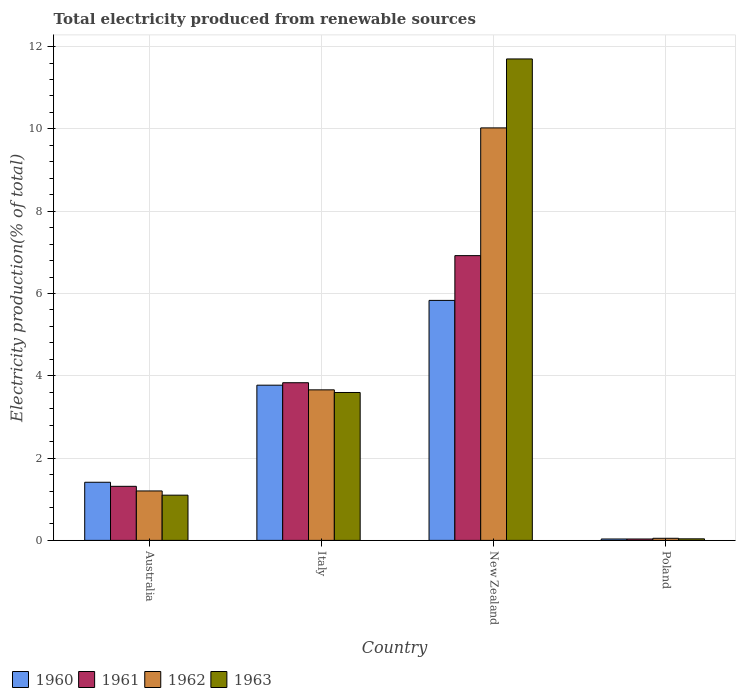How many different coloured bars are there?
Keep it short and to the point. 4. Are the number of bars per tick equal to the number of legend labels?
Your response must be concise. Yes. Are the number of bars on each tick of the X-axis equal?
Give a very brief answer. Yes. How many bars are there on the 3rd tick from the left?
Your answer should be compact. 4. How many bars are there on the 2nd tick from the right?
Your answer should be very brief. 4. What is the total electricity produced in 1960 in New Zealand?
Your answer should be very brief. 5.83. Across all countries, what is the maximum total electricity produced in 1962?
Give a very brief answer. 10.02. Across all countries, what is the minimum total electricity produced in 1960?
Provide a succinct answer. 0.03. In which country was the total electricity produced in 1961 maximum?
Give a very brief answer. New Zealand. What is the total total electricity produced in 1963 in the graph?
Offer a very short reply. 16.43. What is the difference between the total electricity produced in 1961 in Australia and that in New Zealand?
Make the answer very short. -5.61. What is the difference between the total electricity produced in 1963 in Australia and the total electricity produced in 1961 in New Zealand?
Your answer should be very brief. -5.82. What is the average total electricity produced in 1962 per country?
Your answer should be very brief. 3.73. What is the difference between the total electricity produced of/in 1961 and total electricity produced of/in 1963 in Italy?
Give a very brief answer. 0.24. What is the ratio of the total electricity produced in 1960 in New Zealand to that in Poland?
Give a very brief answer. 170.79. Is the total electricity produced in 1960 in Australia less than that in Poland?
Keep it short and to the point. No. What is the difference between the highest and the second highest total electricity produced in 1962?
Offer a very short reply. -8.82. What is the difference between the highest and the lowest total electricity produced in 1963?
Make the answer very short. 11.66. Is the sum of the total electricity produced in 1963 in Italy and Poland greater than the maximum total electricity produced in 1960 across all countries?
Offer a terse response. No. What does the 2nd bar from the left in Poland represents?
Offer a terse response. 1961. What does the 1st bar from the right in Italy represents?
Make the answer very short. 1963. Is it the case that in every country, the sum of the total electricity produced in 1963 and total electricity produced in 1961 is greater than the total electricity produced in 1962?
Make the answer very short. Yes. How many bars are there?
Offer a terse response. 16. What is the difference between two consecutive major ticks on the Y-axis?
Make the answer very short. 2. Does the graph contain any zero values?
Provide a short and direct response. No. Does the graph contain grids?
Your response must be concise. Yes. How many legend labels are there?
Your answer should be compact. 4. What is the title of the graph?
Provide a succinct answer. Total electricity produced from renewable sources. Does "1972" appear as one of the legend labels in the graph?
Give a very brief answer. No. What is the label or title of the Y-axis?
Offer a very short reply. Electricity production(% of total). What is the Electricity production(% of total) in 1960 in Australia?
Your answer should be very brief. 1.41. What is the Electricity production(% of total) in 1961 in Australia?
Ensure brevity in your answer.  1.31. What is the Electricity production(% of total) of 1962 in Australia?
Keep it short and to the point. 1.2. What is the Electricity production(% of total) of 1963 in Australia?
Provide a succinct answer. 1.1. What is the Electricity production(% of total) of 1960 in Italy?
Provide a succinct answer. 3.77. What is the Electricity production(% of total) in 1961 in Italy?
Keep it short and to the point. 3.83. What is the Electricity production(% of total) in 1962 in Italy?
Your answer should be compact. 3.66. What is the Electricity production(% of total) of 1963 in Italy?
Your response must be concise. 3.59. What is the Electricity production(% of total) in 1960 in New Zealand?
Your answer should be very brief. 5.83. What is the Electricity production(% of total) of 1961 in New Zealand?
Provide a short and direct response. 6.92. What is the Electricity production(% of total) in 1962 in New Zealand?
Your response must be concise. 10.02. What is the Electricity production(% of total) in 1963 in New Zealand?
Ensure brevity in your answer.  11.7. What is the Electricity production(% of total) in 1960 in Poland?
Offer a terse response. 0.03. What is the Electricity production(% of total) in 1961 in Poland?
Give a very brief answer. 0.03. What is the Electricity production(% of total) in 1962 in Poland?
Your response must be concise. 0.05. What is the Electricity production(% of total) of 1963 in Poland?
Keep it short and to the point. 0.04. Across all countries, what is the maximum Electricity production(% of total) in 1960?
Offer a very short reply. 5.83. Across all countries, what is the maximum Electricity production(% of total) of 1961?
Keep it short and to the point. 6.92. Across all countries, what is the maximum Electricity production(% of total) of 1962?
Your answer should be compact. 10.02. Across all countries, what is the maximum Electricity production(% of total) in 1963?
Your answer should be compact. 11.7. Across all countries, what is the minimum Electricity production(% of total) of 1960?
Provide a short and direct response. 0.03. Across all countries, what is the minimum Electricity production(% of total) of 1961?
Offer a very short reply. 0.03. Across all countries, what is the minimum Electricity production(% of total) of 1962?
Offer a very short reply. 0.05. Across all countries, what is the minimum Electricity production(% of total) in 1963?
Your answer should be compact. 0.04. What is the total Electricity production(% of total) in 1960 in the graph?
Provide a succinct answer. 11.05. What is the total Electricity production(% of total) of 1962 in the graph?
Your response must be concise. 14.94. What is the total Electricity production(% of total) in 1963 in the graph?
Provide a short and direct response. 16.43. What is the difference between the Electricity production(% of total) in 1960 in Australia and that in Italy?
Ensure brevity in your answer.  -2.36. What is the difference between the Electricity production(% of total) of 1961 in Australia and that in Italy?
Offer a terse response. -2.52. What is the difference between the Electricity production(% of total) of 1962 in Australia and that in Italy?
Make the answer very short. -2.46. What is the difference between the Electricity production(% of total) of 1963 in Australia and that in Italy?
Your response must be concise. -2.5. What is the difference between the Electricity production(% of total) in 1960 in Australia and that in New Zealand?
Make the answer very short. -4.42. What is the difference between the Electricity production(% of total) in 1961 in Australia and that in New Zealand?
Provide a succinct answer. -5.61. What is the difference between the Electricity production(% of total) of 1962 in Australia and that in New Zealand?
Offer a terse response. -8.82. What is the difference between the Electricity production(% of total) of 1963 in Australia and that in New Zealand?
Keep it short and to the point. -10.6. What is the difference between the Electricity production(% of total) of 1960 in Australia and that in Poland?
Your answer should be very brief. 1.38. What is the difference between the Electricity production(% of total) in 1961 in Australia and that in Poland?
Provide a succinct answer. 1.28. What is the difference between the Electricity production(% of total) in 1962 in Australia and that in Poland?
Your answer should be compact. 1.15. What is the difference between the Electricity production(% of total) in 1963 in Australia and that in Poland?
Offer a very short reply. 1.06. What is the difference between the Electricity production(% of total) of 1960 in Italy and that in New Zealand?
Ensure brevity in your answer.  -2.06. What is the difference between the Electricity production(% of total) in 1961 in Italy and that in New Zealand?
Your response must be concise. -3.09. What is the difference between the Electricity production(% of total) of 1962 in Italy and that in New Zealand?
Give a very brief answer. -6.37. What is the difference between the Electricity production(% of total) of 1963 in Italy and that in New Zealand?
Give a very brief answer. -8.11. What is the difference between the Electricity production(% of total) of 1960 in Italy and that in Poland?
Keep it short and to the point. 3.74. What is the difference between the Electricity production(% of total) of 1961 in Italy and that in Poland?
Your answer should be compact. 3.8. What is the difference between the Electricity production(% of total) of 1962 in Italy and that in Poland?
Give a very brief answer. 3.61. What is the difference between the Electricity production(% of total) of 1963 in Italy and that in Poland?
Make the answer very short. 3.56. What is the difference between the Electricity production(% of total) of 1960 in New Zealand and that in Poland?
Offer a very short reply. 5.8. What is the difference between the Electricity production(% of total) of 1961 in New Zealand and that in Poland?
Keep it short and to the point. 6.89. What is the difference between the Electricity production(% of total) in 1962 in New Zealand and that in Poland?
Your answer should be very brief. 9.97. What is the difference between the Electricity production(% of total) of 1963 in New Zealand and that in Poland?
Your answer should be very brief. 11.66. What is the difference between the Electricity production(% of total) in 1960 in Australia and the Electricity production(% of total) in 1961 in Italy?
Provide a succinct answer. -2.42. What is the difference between the Electricity production(% of total) in 1960 in Australia and the Electricity production(% of total) in 1962 in Italy?
Your answer should be very brief. -2.25. What is the difference between the Electricity production(% of total) in 1960 in Australia and the Electricity production(% of total) in 1963 in Italy?
Provide a short and direct response. -2.18. What is the difference between the Electricity production(% of total) in 1961 in Australia and the Electricity production(% of total) in 1962 in Italy?
Keep it short and to the point. -2.34. What is the difference between the Electricity production(% of total) of 1961 in Australia and the Electricity production(% of total) of 1963 in Italy?
Make the answer very short. -2.28. What is the difference between the Electricity production(% of total) in 1962 in Australia and the Electricity production(% of total) in 1963 in Italy?
Your response must be concise. -2.39. What is the difference between the Electricity production(% of total) of 1960 in Australia and the Electricity production(% of total) of 1961 in New Zealand?
Keep it short and to the point. -5.51. What is the difference between the Electricity production(% of total) in 1960 in Australia and the Electricity production(% of total) in 1962 in New Zealand?
Your answer should be very brief. -8.61. What is the difference between the Electricity production(% of total) of 1960 in Australia and the Electricity production(% of total) of 1963 in New Zealand?
Your response must be concise. -10.29. What is the difference between the Electricity production(% of total) of 1961 in Australia and the Electricity production(% of total) of 1962 in New Zealand?
Your response must be concise. -8.71. What is the difference between the Electricity production(% of total) of 1961 in Australia and the Electricity production(% of total) of 1963 in New Zealand?
Keep it short and to the point. -10.39. What is the difference between the Electricity production(% of total) in 1962 in Australia and the Electricity production(% of total) in 1963 in New Zealand?
Provide a succinct answer. -10.5. What is the difference between the Electricity production(% of total) in 1960 in Australia and the Electricity production(% of total) in 1961 in Poland?
Provide a succinct answer. 1.38. What is the difference between the Electricity production(% of total) in 1960 in Australia and the Electricity production(% of total) in 1962 in Poland?
Your answer should be very brief. 1.36. What is the difference between the Electricity production(% of total) in 1960 in Australia and the Electricity production(% of total) in 1963 in Poland?
Provide a succinct answer. 1.37. What is the difference between the Electricity production(% of total) in 1961 in Australia and the Electricity production(% of total) in 1962 in Poland?
Your answer should be compact. 1.26. What is the difference between the Electricity production(% of total) of 1961 in Australia and the Electricity production(% of total) of 1963 in Poland?
Provide a succinct answer. 1.28. What is the difference between the Electricity production(% of total) in 1962 in Australia and the Electricity production(% of total) in 1963 in Poland?
Your answer should be compact. 1.16. What is the difference between the Electricity production(% of total) of 1960 in Italy and the Electricity production(% of total) of 1961 in New Zealand?
Provide a short and direct response. -3.15. What is the difference between the Electricity production(% of total) of 1960 in Italy and the Electricity production(% of total) of 1962 in New Zealand?
Offer a terse response. -6.25. What is the difference between the Electricity production(% of total) of 1960 in Italy and the Electricity production(% of total) of 1963 in New Zealand?
Make the answer very short. -7.93. What is the difference between the Electricity production(% of total) in 1961 in Italy and the Electricity production(% of total) in 1962 in New Zealand?
Offer a very short reply. -6.19. What is the difference between the Electricity production(% of total) of 1961 in Italy and the Electricity production(% of total) of 1963 in New Zealand?
Your response must be concise. -7.87. What is the difference between the Electricity production(% of total) of 1962 in Italy and the Electricity production(% of total) of 1963 in New Zealand?
Give a very brief answer. -8.04. What is the difference between the Electricity production(% of total) in 1960 in Italy and the Electricity production(% of total) in 1961 in Poland?
Offer a terse response. 3.74. What is the difference between the Electricity production(% of total) of 1960 in Italy and the Electricity production(% of total) of 1962 in Poland?
Make the answer very short. 3.72. What is the difference between the Electricity production(% of total) in 1960 in Italy and the Electricity production(% of total) in 1963 in Poland?
Provide a succinct answer. 3.73. What is the difference between the Electricity production(% of total) of 1961 in Italy and the Electricity production(% of total) of 1962 in Poland?
Provide a succinct answer. 3.78. What is the difference between the Electricity production(% of total) in 1961 in Italy and the Electricity production(% of total) in 1963 in Poland?
Your answer should be very brief. 3.79. What is the difference between the Electricity production(% of total) of 1962 in Italy and the Electricity production(% of total) of 1963 in Poland?
Give a very brief answer. 3.62. What is the difference between the Electricity production(% of total) in 1960 in New Zealand and the Electricity production(% of total) in 1961 in Poland?
Provide a short and direct response. 5.8. What is the difference between the Electricity production(% of total) in 1960 in New Zealand and the Electricity production(% of total) in 1962 in Poland?
Ensure brevity in your answer.  5.78. What is the difference between the Electricity production(% of total) in 1960 in New Zealand and the Electricity production(% of total) in 1963 in Poland?
Provide a succinct answer. 5.79. What is the difference between the Electricity production(% of total) in 1961 in New Zealand and the Electricity production(% of total) in 1962 in Poland?
Provide a short and direct response. 6.87. What is the difference between the Electricity production(% of total) in 1961 in New Zealand and the Electricity production(% of total) in 1963 in Poland?
Keep it short and to the point. 6.88. What is the difference between the Electricity production(% of total) of 1962 in New Zealand and the Electricity production(% of total) of 1963 in Poland?
Make the answer very short. 9.99. What is the average Electricity production(% of total) of 1960 per country?
Offer a very short reply. 2.76. What is the average Electricity production(% of total) of 1961 per country?
Keep it short and to the point. 3.02. What is the average Electricity production(% of total) in 1962 per country?
Offer a terse response. 3.73. What is the average Electricity production(% of total) of 1963 per country?
Ensure brevity in your answer.  4.11. What is the difference between the Electricity production(% of total) of 1960 and Electricity production(% of total) of 1961 in Australia?
Provide a short and direct response. 0.1. What is the difference between the Electricity production(% of total) of 1960 and Electricity production(% of total) of 1962 in Australia?
Offer a very short reply. 0.21. What is the difference between the Electricity production(% of total) in 1960 and Electricity production(% of total) in 1963 in Australia?
Your answer should be very brief. 0.31. What is the difference between the Electricity production(% of total) of 1961 and Electricity production(% of total) of 1962 in Australia?
Offer a very short reply. 0.11. What is the difference between the Electricity production(% of total) of 1961 and Electricity production(% of total) of 1963 in Australia?
Make the answer very short. 0.21. What is the difference between the Electricity production(% of total) in 1962 and Electricity production(% of total) in 1963 in Australia?
Provide a short and direct response. 0.1. What is the difference between the Electricity production(% of total) in 1960 and Electricity production(% of total) in 1961 in Italy?
Keep it short and to the point. -0.06. What is the difference between the Electricity production(% of total) in 1960 and Electricity production(% of total) in 1962 in Italy?
Provide a succinct answer. 0.11. What is the difference between the Electricity production(% of total) in 1960 and Electricity production(% of total) in 1963 in Italy?
Your answer should be very brief. 0.18. What is the difference between the Electricity production(% of total) in 1961 and Electricity production(% of total) in 1962 in Italy?
Make the answer very short. 0.17. What is the difference between the Electricity production(% of total) of 1961 and Electricity production(% of total) of 1963 in Italy?
Provide a succinct answer. 0.24. What is the difference between the Electricity production(% of total) of 1962 and Electricity production(% of total) of 1963 in Italy?
Make the answer very short. 0.06. What is the difference between the Electricity production(% of total) of 1960 and Electricity production(% of total) of 1961 in New Zealand?
Provide a succinct answer. -1.09. What is the difference between the Electricity production(% of total) in 1960 and Electricity production(% of total) in 1962 in New Zealand?
Provide a succinct answer. -4.19. What is the difference between the Electricity production(% of total) in 1960 and Electricity production(% of total) in 1963 in New Zealand?
Offer a very short reply. -5.87. What is the difference between the Electricity production(% of total) in 1961 and Electricity production(% of total) in 1962 in New Zealand?
Ensure brevity in your answer.  -3.1. What is the difference between the Electricity production(% of total) of 1961 and Electricity production(% of total) of 1963 in New Zealand?
Make the answer very short. -4.78. What is the difference between the Electricity production(% of total) of 1962 and Electricity production(% of total) of 1963 in New Zealand?
Offer a very short reply. -1.68. What is the difference between the Electricity production(% of total) of 1960 and Electricity production(% of total) of 1962 in Poland?
Ensure brevity in your answer.  -0.02. What is the difference between the Electricity production(% of total) of 1960 and Electricity production(% of total) of 1963 in Poland?
Your answer should be compact. -0. What is the difference between the Electricity production(% of total) in 1961 and Electricity production(% of total) in 1962 in Poland?
Make the answer very short. -0.02. What is the difference between the Electricity production(% of total) of 1961 and Electricity production(% of total) of 1963 in Poland?
Your response must be concise. -0. What is the difference between the Electricity production(% of total) of 1962 and Electricity production(% of total) of 1963 in Poland?
Your answer should be compact. 0.01. What is the ratio of the Electricity production(% of total) in 1960 in Australia to that in Italy?
Offer a terse response. 0.37. What is the ratio of the Electricity production(% of total) in 1961 in Australia to that in Italy?
Offer a very short reply. 0.34. What is the ratio of the Electricity production(% of total) of 1962 in Australia to that in Italy?
Make the answer very short. 0.33. What is the ratio of the Electricity production(% of total) of 1963 in Australia to that in Italy?
Keep it short and to the point. 0.31. What is the ratio of the Electricity production(% of total) of 1960 in Australia to that in New Zealand?
Your answer should be compact. 0.24. What is the ratio of the Electricity production(% of total) in 1961 in Australia to that in New Zealand?
Offer a very short reply. 0.19. What is the ratio of the Electricity production(% of total) in 1962 in Australia to that in New Zealand?
Your answer should be very brief. 0.12. What is the ratio of the Electricity production(% of total) in 1963 in Australia to that in New Zealand?
Your answer should be compact. 0.09. What is the ratio of the Electricity production(% of total) in 1960 in Australia to that in Poland?
Provide a succinct answer. 41.37. What is the ratio of the Electricity production(% of total) in 1961 in Australia to that in Poland?
Offer a terse response. 38.51. What is the ratio of the Electricity production(% of total) of 1962 in Australia to that in Poland?
Make the answer very short. 23.61. What is the ratio of the Electricity production(% of total) of 1963 in Australia to that in Poland?
Make the answer very short. 29. What is the ratio of the Electricity production(% of total) of 1960 in Italy to that in New Zealand?
Make the answer very short. 0.65. What is the ratio of the Electricity production(% of total) in 1961 in Italy to that in New Zealand?
Offer a terse response. 0.55. What is the ratio of the Electricity production(% of total) in 1962 in Italy to that in New Zealand?
Provide a short and direct response. 0.36. What is the ratio of the Electricity production(% of total) of 1963 in Italy to that in New Zealand?
Your answer should be compact. 0.31. What is the ratio of the Electricity production(% of total) in 1960 in Italy to that in Poland?
Your answer should be very brief. 110.45. What is the ratio of the Electricity production(% of total) in 1961 in Italy to that in Poland?
Provide a short and direct response. 112.3. What is the ratio of the Electricity production(% of total) of 1962 in Italy to that in Poland?
Provide a short and direct response. 71.88. What is the ratio of the Electricity production(% of total) of 1963 in Italy to that in Poland?
Provide a short and direct response. 94.84. What is the ratio of the Electricity production(% of total) of 1960 in New Zealand to that in Poland?
Offer a very short reply. 170.79. What is the ratio of the Electricity production(% of total) in 1961 in New Zealand to that in Poland?
Ensure brevity in your answer.  202.83. What is the ratio of the Electricity production(% of total) of 1962 in New Zealand to that in Poland?
Keep it short and to the point. 196.95. What is the ratio of the Electricity production(% of total) of 1963 in New Zealand to that in Poland?
Your answer should be compact. 308.73. What is the difference between the highest and the second highest Electricity production(% of total) of 1960?
Ensure brevity in your answer.  2.06. What is the difference between the highest and the second highest Electricity production(% of total) in 1961?
Give a very brief answer. 3.09. What is the difference between the highest and the second highest Electricity production(% of total) of 1962?
Ensure brevity in your answer.  6.37. What is the difference between the highest and the second highest Electricity production(% of total) of 1963?
Make the answer very short. 8.11. What is the difference between the highest and the lowest Electricity production(% of total) in 1960?
Make the answer very short. 5.8. What is the difference between the highest and the lowest Electricity production(% of total) of 1961?
Your response must be concise. 6.89. What is the difference between the highest and the lowest Electricity production(% of total) in 1962?
Keep it short and to the point. 9.97. What is the difference between the highest and the lowest Electricity production(% of total) of 1963?
Your answer should be compact. 11.66. 